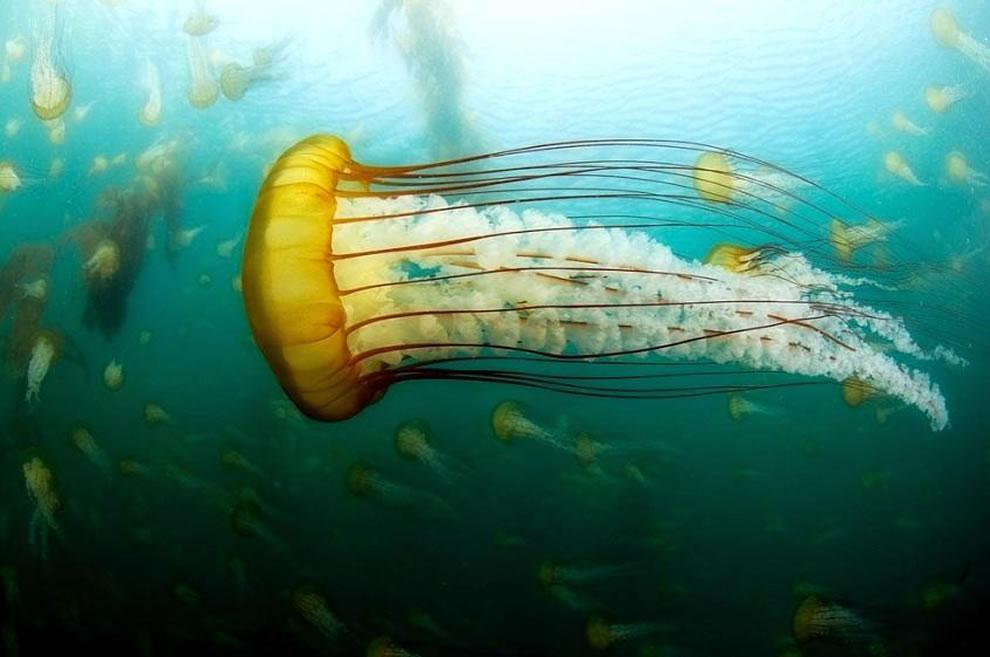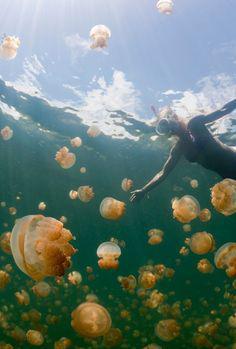The first image is the image on the left, the second image is the image on the right. Analyze the images presented: Is the assertion "At least one of the jellyfish clearly has white spots all over the bell." valid? Answer yes or no. No. The first image is the image on the left, the second image is the image on the right. Given the left and right images, does the statement "in the left image a jellyfish is swimming toward the left" hold true? Answer yes or no. Yes. 